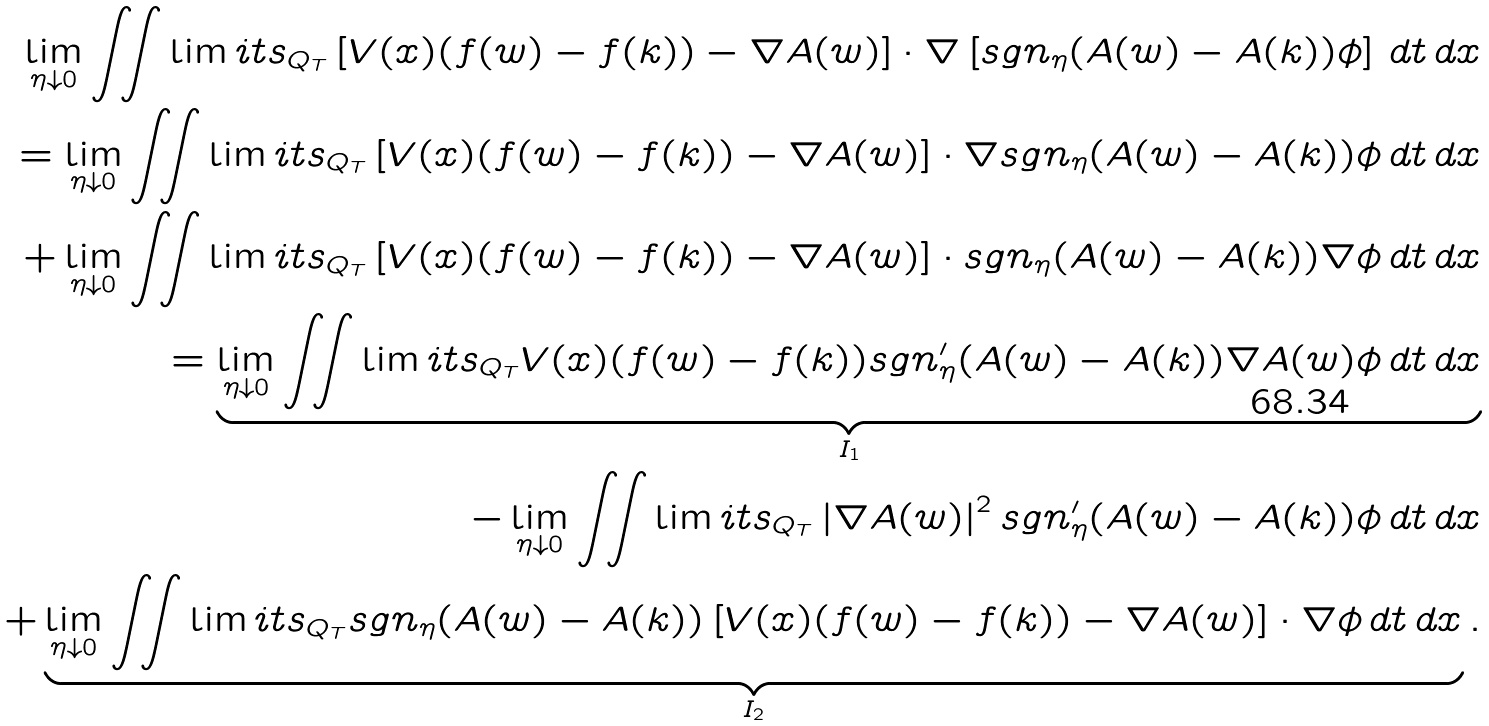Convert formula to latex. <formula><loc_0><loc_0><loc_500><loc_500>\lim _ { \eta \downarrow 0 } \iint \lim i t s _ { Q _ { T } } \left [ V ( x ) ( f ( w ) - f ( k ) ) - \nabla A ( w ) \right ] \cdot \nabla \left [ s g n _ { \eta } ( A ( w ) - A ( k ) ) \phi \right ] \, d t \, d x \\ = \lim _ { \eta \downarrow 0 } \iint \lim i t s _ { Q _ { T } } \left [ V ( x ) ( f ( w ) - f ( k ) ) - \nabla A ( w ) \right ] \cdot \nabla s g n _ { \eta } ( A ( w ) - A ( k ) ) \phi \, d t \, d x \\ + \lim _ { \eta \downarrow 0 } \iint \lim i t s _ { Q _ { T } } \left [ V ( x ) ( f ( w ) - f ( k ) ) - \nabla A ( w ) \right ] \cdot s g n _ { \eta } ( A ( w ) - A ( k ) ) \nabla \phi \, d t \, d x \\ = \underbrace { \lim _ { \eta \downarrow 0 } \iint \lim i t s _ { Q _ { T } } V ( x ) ( f ( w ) - f ( k ) ) s g n _ { \eta } ^ { \prime } ( A ( w ) - A ( k ) ) \nabla A ( w ) \phi \, d t \, d x } _ { I _ { 1 } } \\ - \lim _ { \eta \downarrow 0 } \iint \lim i t s _ { Q _ { T } } \left | \nabla A ( w ) \right | ^ { 2 } s g n _ { \eta } ^ { \prime } ( A ( w ) - A ( k ) ) \phi \, d t \, d x \\ + \underbrace { \lim _ { \eta \downarrow 0 } \iint \lim i t s _ { Q _ { T } } s g n _ { \eta } ( A ( w ) - A ( k ) ) \left [ V ( x ) ( f ( w ) - f ( k ) ) - \nabla A ( w ) \right ] \cdot \nabla \phi \, d t \, d x } _ { I _ { 2 } } .</formula> 